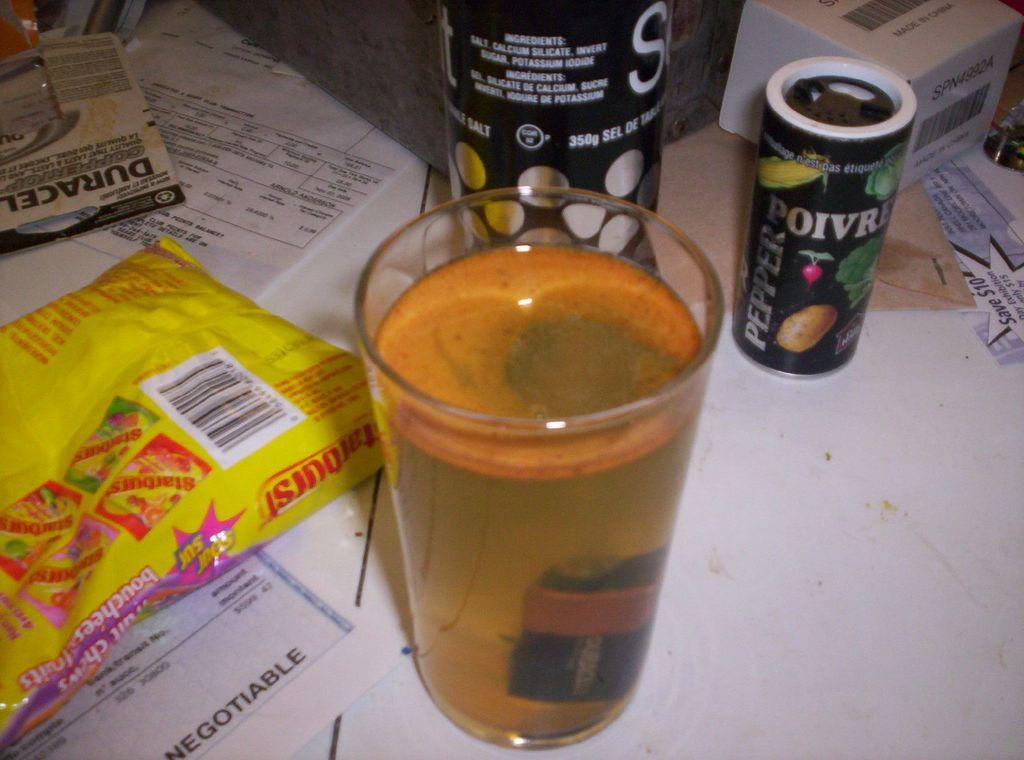<image>
Share a concise interpretation of the image provided. Full cup of beer next to a Poivre Pepper can. 